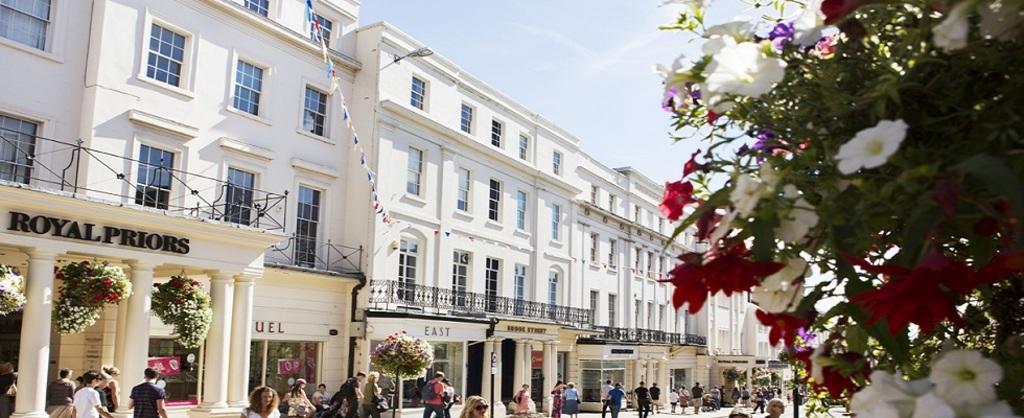In one or two sentences, can you explain what this image depicts? There are few buildings in the left corner which are white in color and there are few people standing in front of it and there are few flowers which are in white and red color in the right corner. 